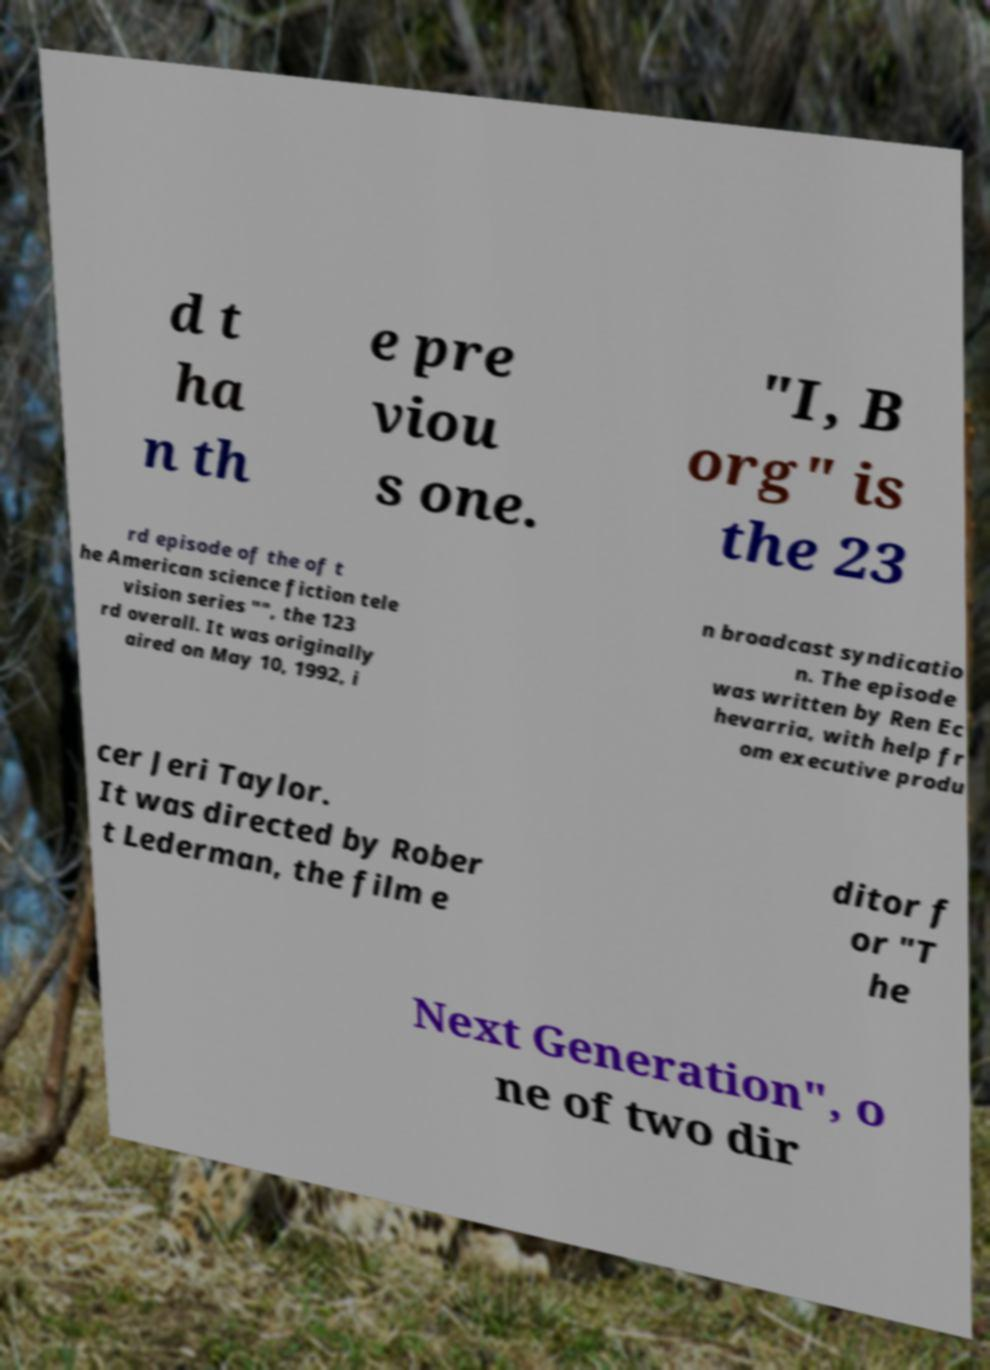Please identify and transcribe the text found in this image. d t ha n th e pre viou s one. "I, B org" is the 23 rd episode of the of t he American science fiction tele vision series "", the 123 rd overall. It was originally aired on May 10, 1992, i n broadcast syndicatio n. The episode was written by Ren Ec hevarria, with help fr om executive produ cer Jeri Taylor. It was directed by Rober t Lederman, the film e ditor f or "T he Next Generation", o ne of two dir 